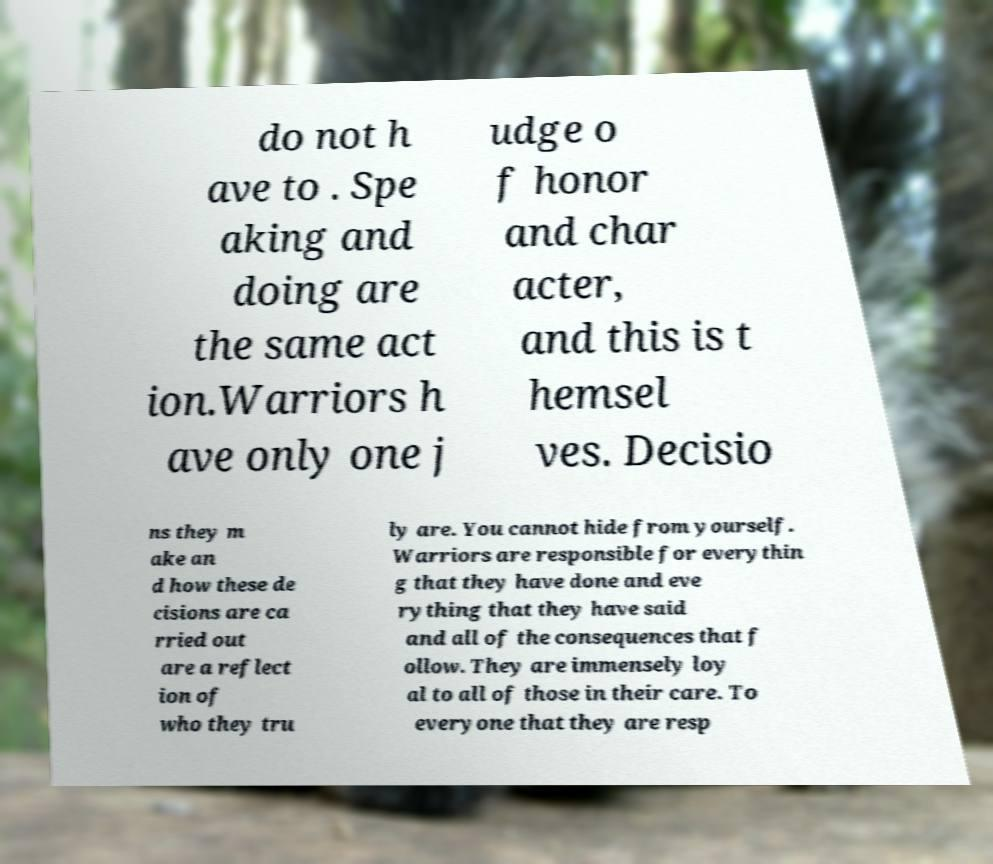Can you read and provide the text displayed in the image?This photo seems to have some interesting text. Can you extract and type it out for me? do not h ave to . Spe aking and doing are the same act ion.Warriors h ave only one j udge o f honor and char acter, and this is t hemsel ves. Decisio ns they m ake an d how these de cisions are ca rried out are a reflect ion of who they tru ly are. You cannot hide from yourself. Warriors are responsible for everythin g that they have done and eve rything that they have said and all of the consequences that f ollow. They are immensely loy al to all of those in their care. To everyone that they are resp 